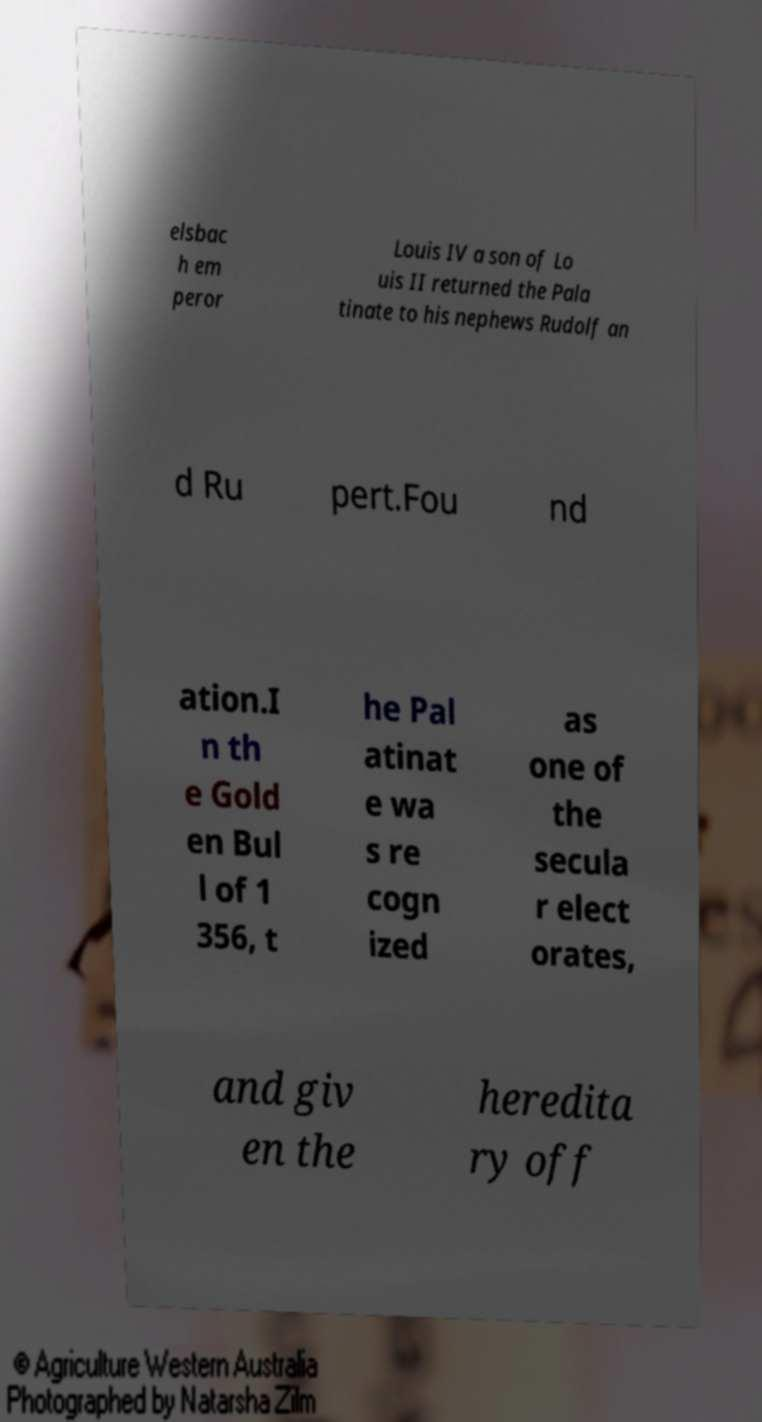Please read and relay the text visible in this image. What does it say? elsbac h em peror Louis IV a son of Lo uis II returned the Pala tinate to his nephews Rudolf an d Ru pert.Fou nd ation.I n th e Gold en Bul l of 1 356, t he Pal atinat e wa s re cogn ized as one of the secula r elect orates, and giv en the heredita ry off 